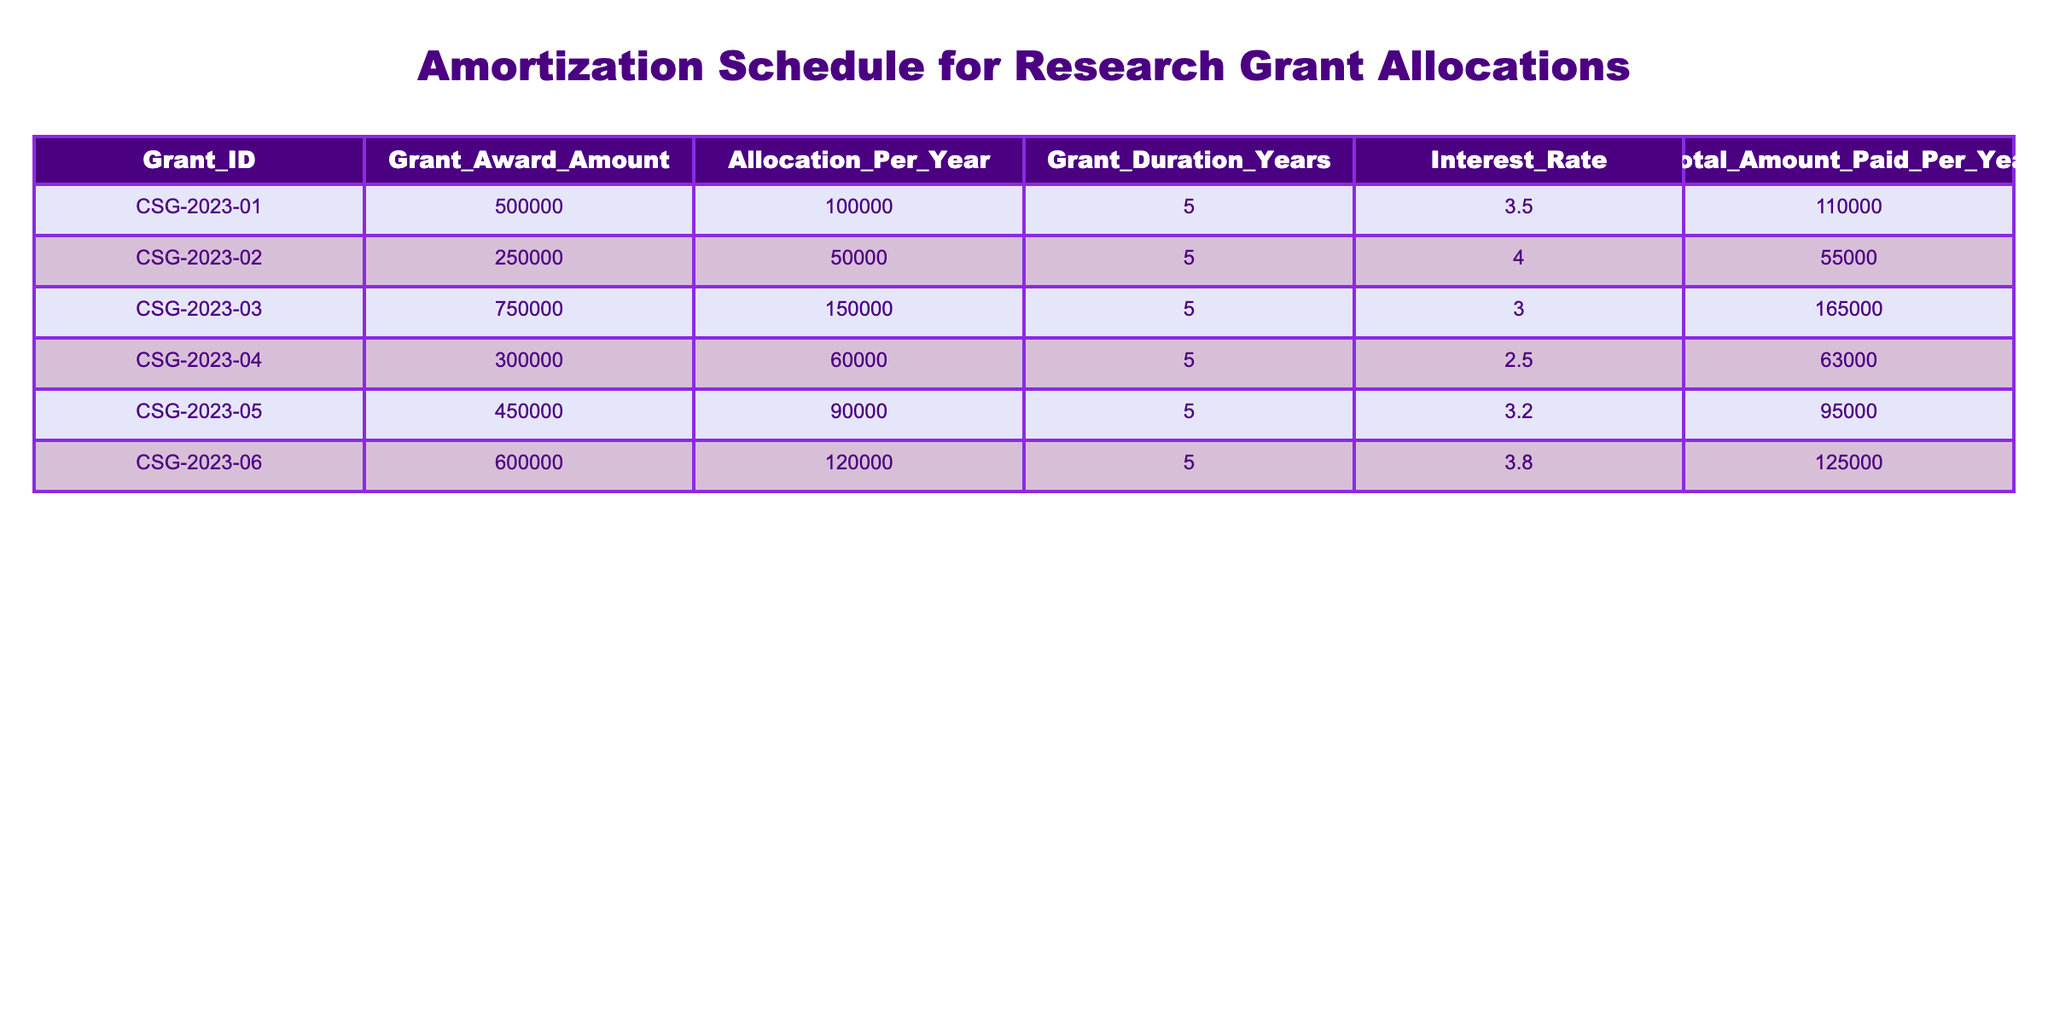What is the total grant award amount for CSG-2023-03? The total grant award amount for CSG-2023-03 is directly listed in the table under the Grant_Award_Amount column. It shows 750000.
Answer: 750000 What is the allocation per year for the grant CSG-2023-05? The allocation per year for CSG-2023-05 is directly listed in the Allocation_Per_Year column of the table. It shows 90000.
Answer: 90000 Which grant has the highest interest rate? By comparing the Interest_Rate column, CSG-2023-02 has the highest interest rate at 4.0.
Answer: CSG-2023-02 What is the average total amount paid per year across all grants? To find the average, we sum all the values in the Total_Amount_Paid_Per_Year column: 110000 + 55000 + 165000 + 63000 + 95000 + 125000 = 600000. There are 6 grants, so 600000 divided by 6 equals 100000.
Answer: 100000 Is the allocation per year for CSG-2023-01 greater than the allocation per year for CSG-2023-04? We look at Allocation_Per_Year for both grants: CSG-2023-01 has 100000 and CSG-2023-04 has 60000. Since 100000 is greater than 60000, the statement is true.
Answer: Yes Which grant has the lowest total amount paid per year? By examining the Total_Amount_Paid_Per_Year column, CSG-2023-02 with 55000 is the lowest when compared to others.
Answer: CSG-2023-02 What is the difference in grant award amounts between CSG-2023-01 and CSG-2023-06? We subtract the Grant_Award_Amount of CSG-2023-01 from that of CSG-2023-06: 600000 - 500000 equals 100000, showing the difference between the two grants.
Answer: 100000 How many grants have an allocation per year that exceeds 100000? By reviewing the Allocation_Per_Year column, we find CSG-2023-01, CSG-2023-03, and CSG-2023-06 (100000, 150000, and 120000 respectively). This totals to 3 grants exceeding the amount.
Answer: 3 If the grants are ranked by interest rate, which grant is in the second position? Listing all grants by interest rate, we find their order: 1. CSG-2023-02 (4.0), 2. CSG-2023-06 (3.8), making CSG-2023-06 the second grant by interest rate.
Answer: CSG-2023-06 